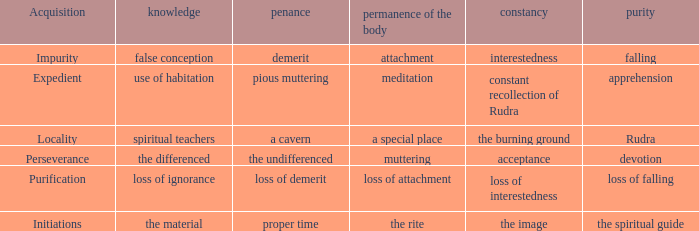 what's the permanence of the body where purity is apprehension Meditation. 